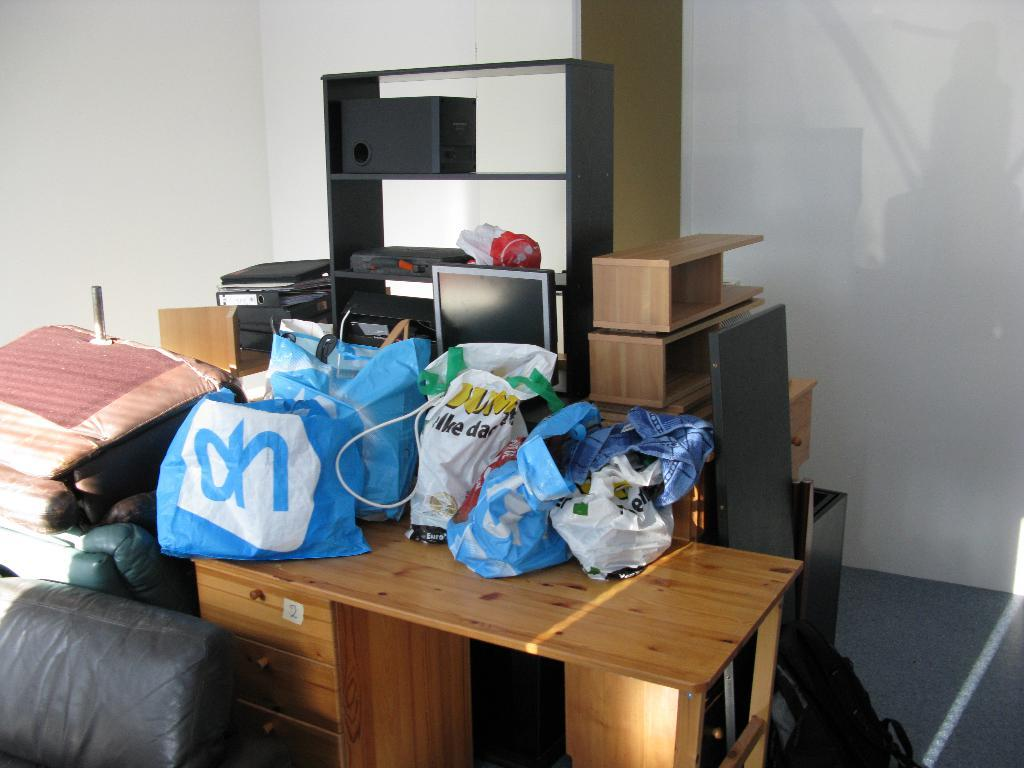<image>
Give a short and clear explanation of the subsequent image. a blue bag in a pile that has what looks to be the letter N on it 